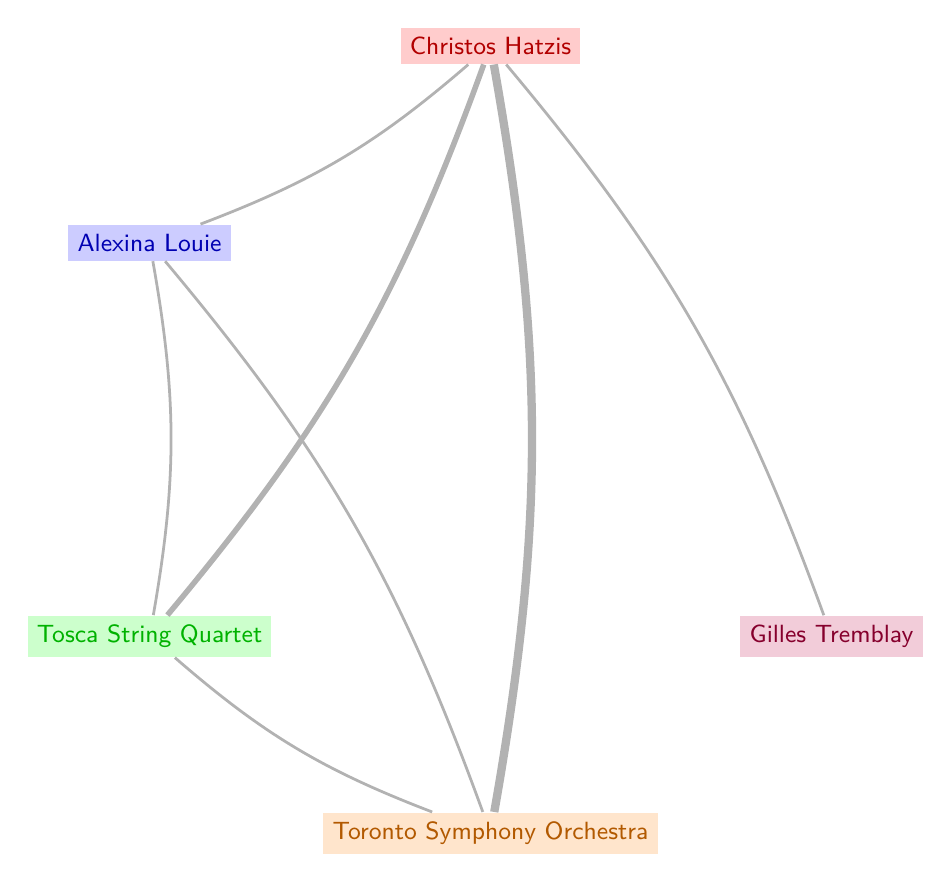What is the total number of nodes in the diagram? The diagram contains five distinct entities: Christos Hatzis, Alexina Louie, Tosca String Quartet, Toronto Symphony Orchestra, and Gilles Tremblay. Counting these yields a total of five nodes.
Answer: 5 What is the strongest connection involving Christos Hatzis? In the diagram, the strongest connection (the thickest line) emanating from Christos Hatzis is to the Toronto Symphony Orchestra, indicated by the highest value (3) of the connection.
Answer: Toronto Symphony Orchestra How many collaborations are there between Alexina Louie and the Tosca String Quartet? The diagram shows a single connection (edge) linking Alexina Louie to the Tosca String Quartet, which is derived from the provided relationship data, making this a straightforward tally of one collaboration.
Answer: 1 Which node has the most direct connections? By analyzing the connections, Christos Hatzis is directly linked to four nodes (Alexina Louie, Tosca String Quartet, Toronto Symphony Orchestra, and Gilles Tremblay), the most of any entity in the diagram.
Answer: Christos Hatzis How many pairs of nodes are connected by a single collaboration? Upon observing the diagram, both Alexina Louie to Tosca String Quartet and Alexina Louie to Toronto Symphony Orchestra have one connection each, while the Toronto Symphony Orchestra has one connection to the Tosca String Quartet. Adding these, we have three pairs in total, indicating individual collaborations.
Answer: 3 What is the relationship value between Christos Hatzis and Gilles Tremblay? The diagram specifies a connection between Christos Hatzis and Gilles Tremblay with a value of 1, indicating a direct collaboration where the value represents the strength or significance of their collaboration.
Answer: 1 Which node connects the Toronto Symphony Orchestra to the Tosca String Quartet? The relationship between the Toronto Symphony Orchestra and the Tosca String Quartet is directly indicated in the diagram by a singular connection (edge) between them, thus they are interconnected without any intermediary.
Answer: Toronto Symphony Orchestra Which composer directly influenced Christos Hatzis besides Alexina Louie? Besides Alexina Louie, the diagram indicates Gilles Tremblay as a composer closely related to Christos Hatzis, confirming a direct influence through their connection.
Answer: Gilles Tremblay What is the value of the link between Christos Hatzis and the Tosca String Quartet? The link between Christos Hatzis and the Tosca String Quartet in the diagram is represented by a value of 2, which denotes the significance of their collaborative relationship.
Answer: 2 